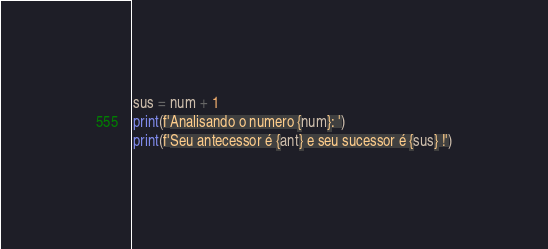<code> <loc_0><loc_0><loc_500><loc_500><_Python_>sus = num + 1
print(f'Analisando o numero {num}: ')
print(f'Seu antecessor é {ant} e seu sucessor é {sus} !')</code> 